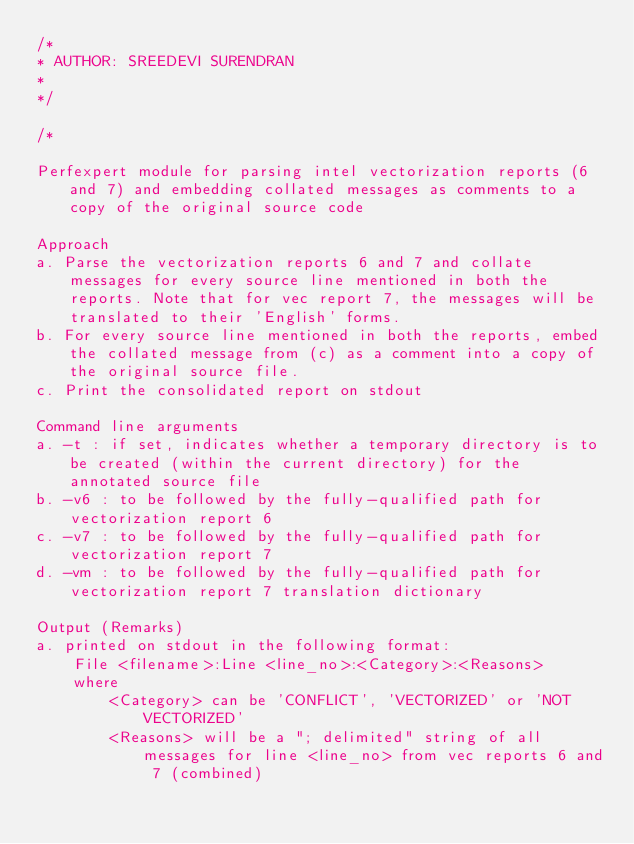<code> <loc_0><loc_0><loc_500><loc_500><_C++_>/*
* AUTHOR: SREEDEVI SURENDRAN
*
*/

/* 

Perfexpert module for parsing intel vectorization reports (6 and 7) and embedding collated messages as comments to a copy of the original source code

Approach
a. Parse the vectorization reports 6 and 7 and collate messages for every source line mentioned in both the reports. Note that for vec report 7, the messages will be translated to their 'English' forms.
b. For every source line mentioned in both the reports, embed the collated message from (c) as a comment into a copy of the original source file.
c. Print the consolidated report on stdout

Command line arguments
a. -t : if set, indicates whether a temporary directory is to be created (within the current directory) for the annotated source file
b. -v6 : to be followed by the fully-qualified path for vectorization report 6
c. -v7 : to be followed by the fully-qualified path for vectorization report 7
d. -vm : to be followed by the fully-qualified path for vectorization report 7 translation dictionary 

Output (Remarks)
a. printed on stdout in the following format:
    File <filename>:Line <line_no>:<Category>:<Reasons>
	where 
		<Category> can be 'CONFLICT', 'VECTORIZED' or 'NOT VECTORIZED' 
		<Reasons> will be a "; delimited" string of all messages for line <line_no> from vec reports 6 and 7 (combined)</code> 